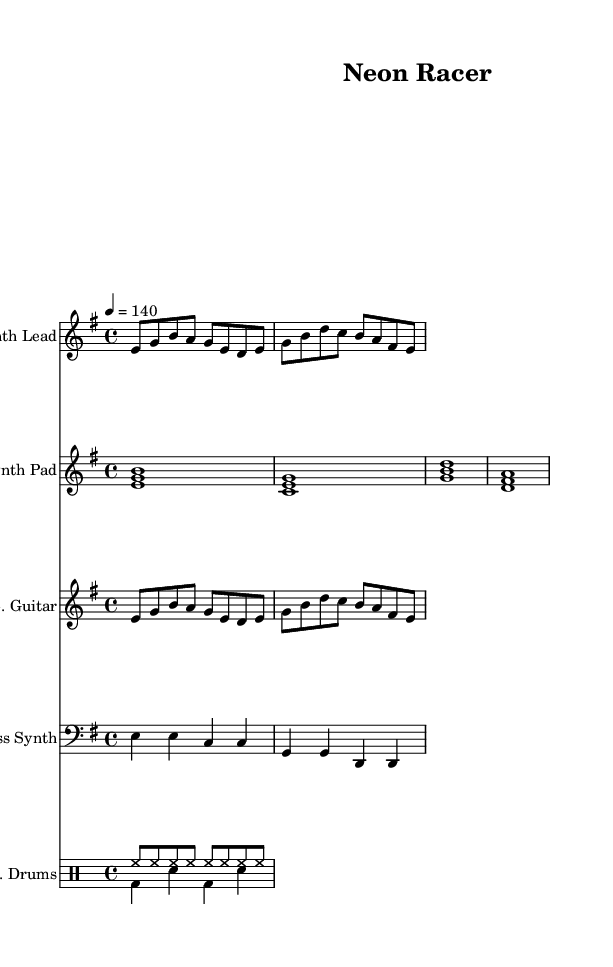What is the key signature of this music? The key signature is E minor, which has one sharp (F#) and suggests a darker sound characteristic of minor keys.
Answer: E minor What is the time signature of this piece? The time signature is 4/4, which means there are four beats per measure, and it is a common time signature in rock music, giving it a steady, driving feel.
Answer: 4/4 What is the tempo marking for this composition? The tempo marking is 140 beats per minute, which indicates a moderately fast pace that is typical for energetic rock and synth music.
Answer: 140 How many measures are in the synth lead part? The synth lead part consists of four measures, as evidenced by the groupings of notes separated by vertical lines on the sheet music.
Answer: 4 What type of instrument plays the bass synth? The bass synth is played on a synthesized bass instrument, which is indicated by the use of a bass clef and the low-frequency notes typical of synth bass sounds.
Answer: Bass Synth What rhythmic pattern is used for the electric drums? The electric drums utilize a standard rock drum pattern featuring a mix of hi-hat and bass drum sounds following a consistent rhythm structure that supports the other instruments.
Answer: Rock drum pattern What chord structure is represented in the synth pad? The synth pad features major and minor chords in stacked notes (e.g., E minor and C major), creating a lush harmonic background typical for synth rock.
Answer: Major and minor chords 